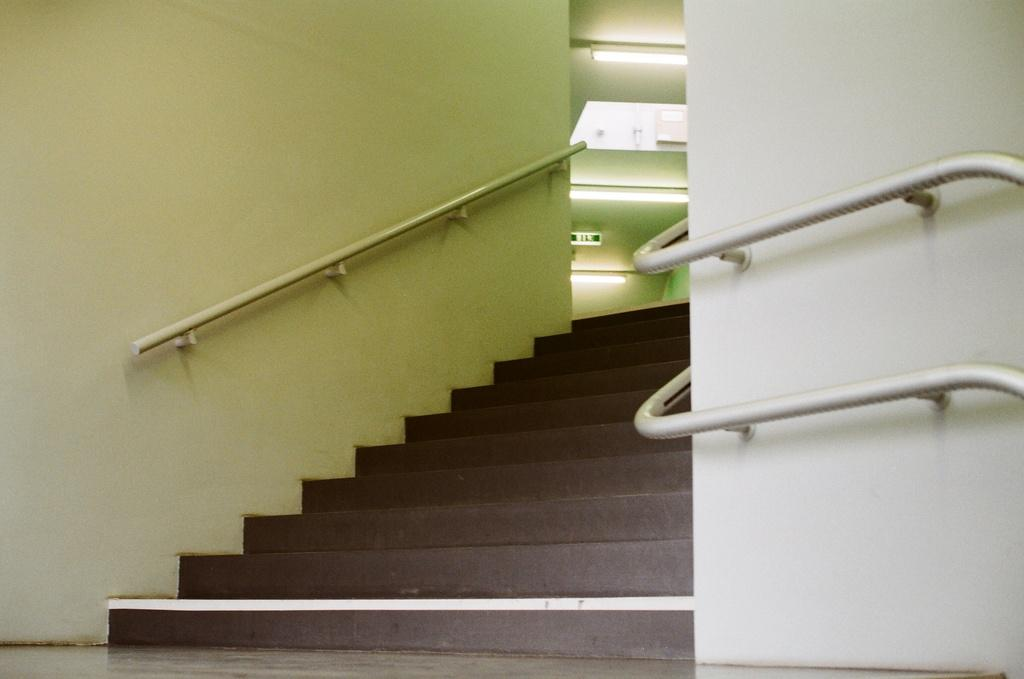What type of architectural feature is present in the image? There are stairs in the image. What safety feature is present alongside the stairs? There are railings in the image. What encloses the area around the stairs and railings? There are walls in the image. What provides illumination in the image? There are lights in the image. What type of land is depicted in the image? The image does not depict any land; it features stairs, railings, walls, and lights. What fictional character can be seen interacting with the stairs in the image? There are no fictional characters present in the image; it only features stairs, railings, walls, and lights. 